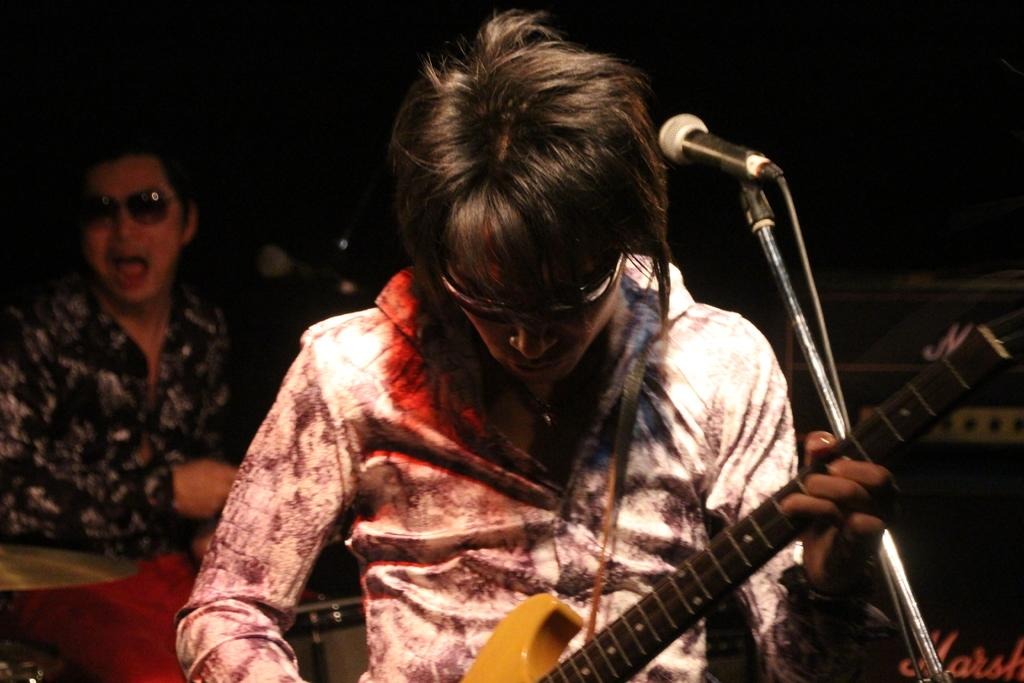What is the main activity being performed by the person in the image? There is a person playing a guitar in the image. Can you describe the appearance of the person playing the guitar? The person is wearing glasses. What object is present that is commonly used for amplifying sound? There is a microphone in the image. Is there anyone else visible in the image? Yes, there is another person standing in the background of the image. What type of scarecrow is standing next to the person playing the guitar in the image? There is no scarecrow present in the image; it features a person playing a guitar and another person standing in the background. 